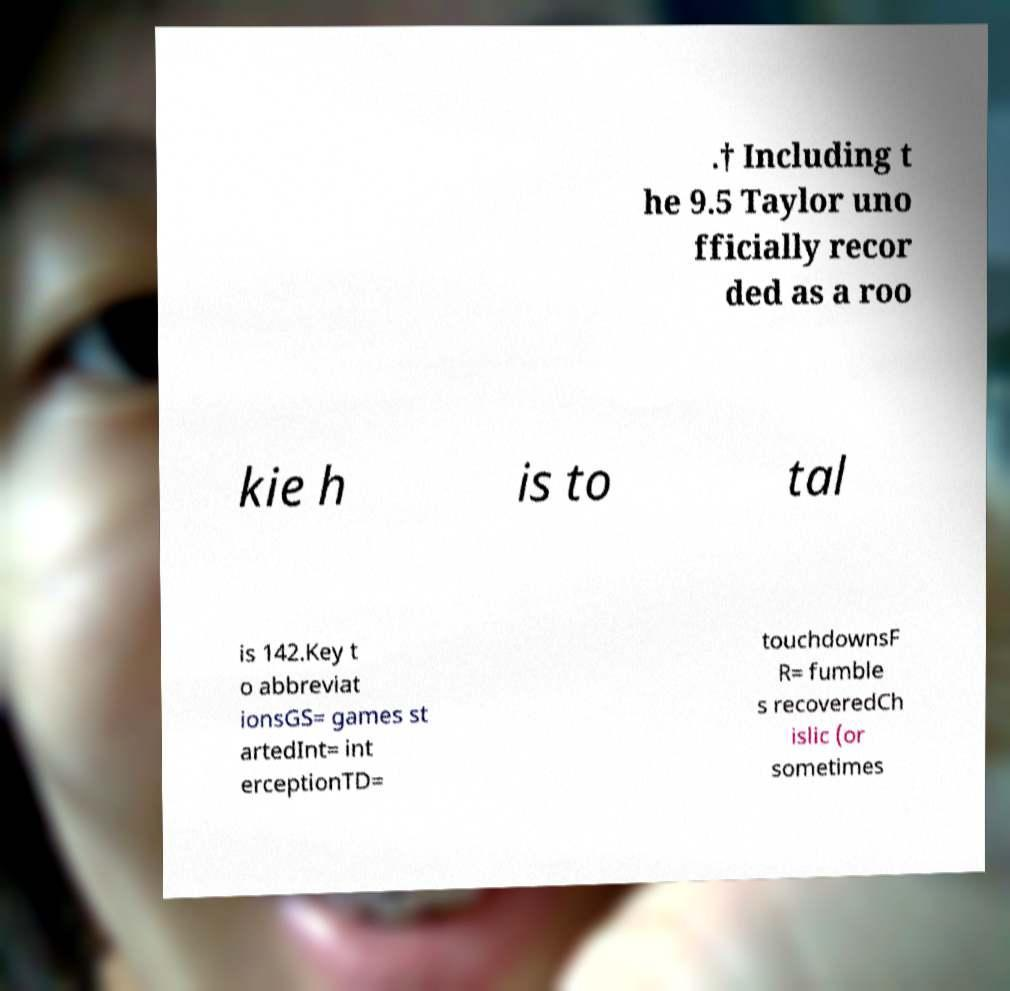Can you read and provide the text displayed in the image?This photo seems to have some interesting text. Can you extract and type it out for me? .† Including t he 9.5 Taylor uno fficially recor ded as a roo kie h is to tal is 142.Key t o abbreviat ionsGS= games st artedInt= int erceptionTD= touchdownsF R= fumble s recoveredCh islic (or sometimes 